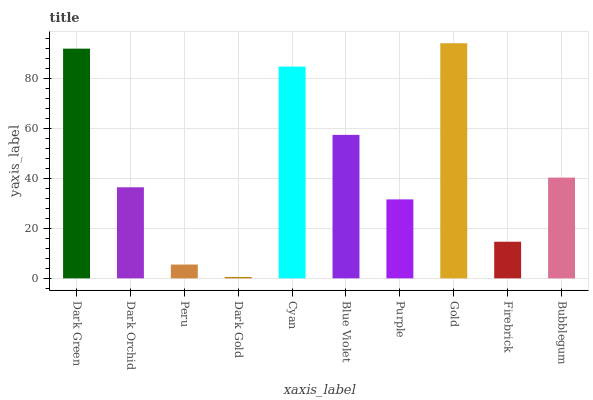Is Dark Gold the minimum?
Answer yes or no. Yes. Is Gold the maximum?
Answer yes or no. Yes. Is Dark Orchid the minimum?
Answer yes or no. No. Is Dark Orchid the maximum?
Answer yes or no. No. Is Dark Green greater than Dark Orchid?
Answer yes or no. Yes. Is Dark Orchid less than Dark Green?
Answer yes or no. Yes. Is Dark Orchid greater than Dark Green?
Answer yes or no. No. Is Dark Green less than Dark Orchid?
Answer yes or no. No. Is Bubblegum the high median?
Answer yes or no. Yes. Is Dark Orchid the low median?
Answer yes or no. Yes. Is Gold the high median?
Answer yes or no. No. Is Dark Gold the low median?
Answer yes or no. No. 